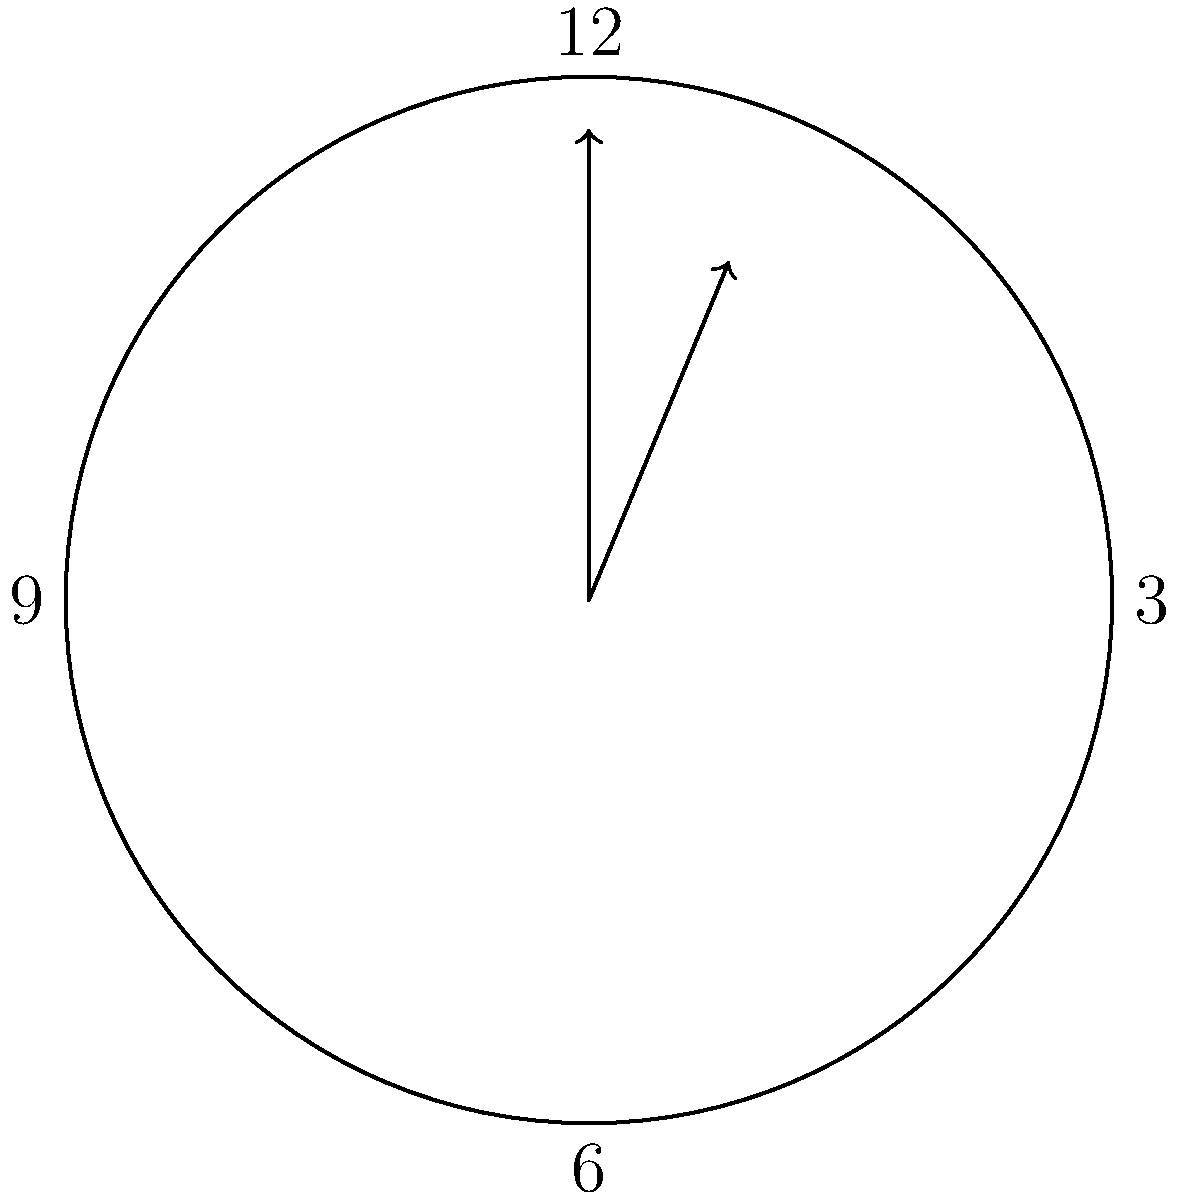A student with Asperger's Syndrome is learning about angles using a clock face. At 2:15, what is the measure of the smaller angle formed between the hour and minute hands? To solve this problem, let's break it down into steps:

1) First, recall that a clock face is divided into 360°, with each hour mark representing 30° (360° ÷ 12 = 30°).

2) At 2:00, the hour hand will have moved 2 * 30° = 60° from the 12 o'clock position.

3) However, by 2:15, the hour hand will have moved a bit further. In 1 hour, it moves 30°, so in 15 minutes (1/4 hour), it will move an additional 30° * 1/4 = 7.5°.

4) So at 2:15, the hour hand will be at 60° + 7.5° = 67.5° from the 12 o'clock position.

5) The minute hand moves much faster. It makes a complete rotation in 60 minutes, so it moves at a rate of 360° ÷ 60 = 6° per minute.

6) At 15 minutes past the hour, the minute hand will have moved 15 * 6° = 90° from the 12 o'clock position.

7) The angle between the hands is the absolute difference between their positions: |90° - 67.5°| = 22.5°.

This approach breaks down the problem into manageable steps, which can be helpful for students with Asperger's Syndrome who often excel at systematic problem-solving.
Answer: 22.5° 